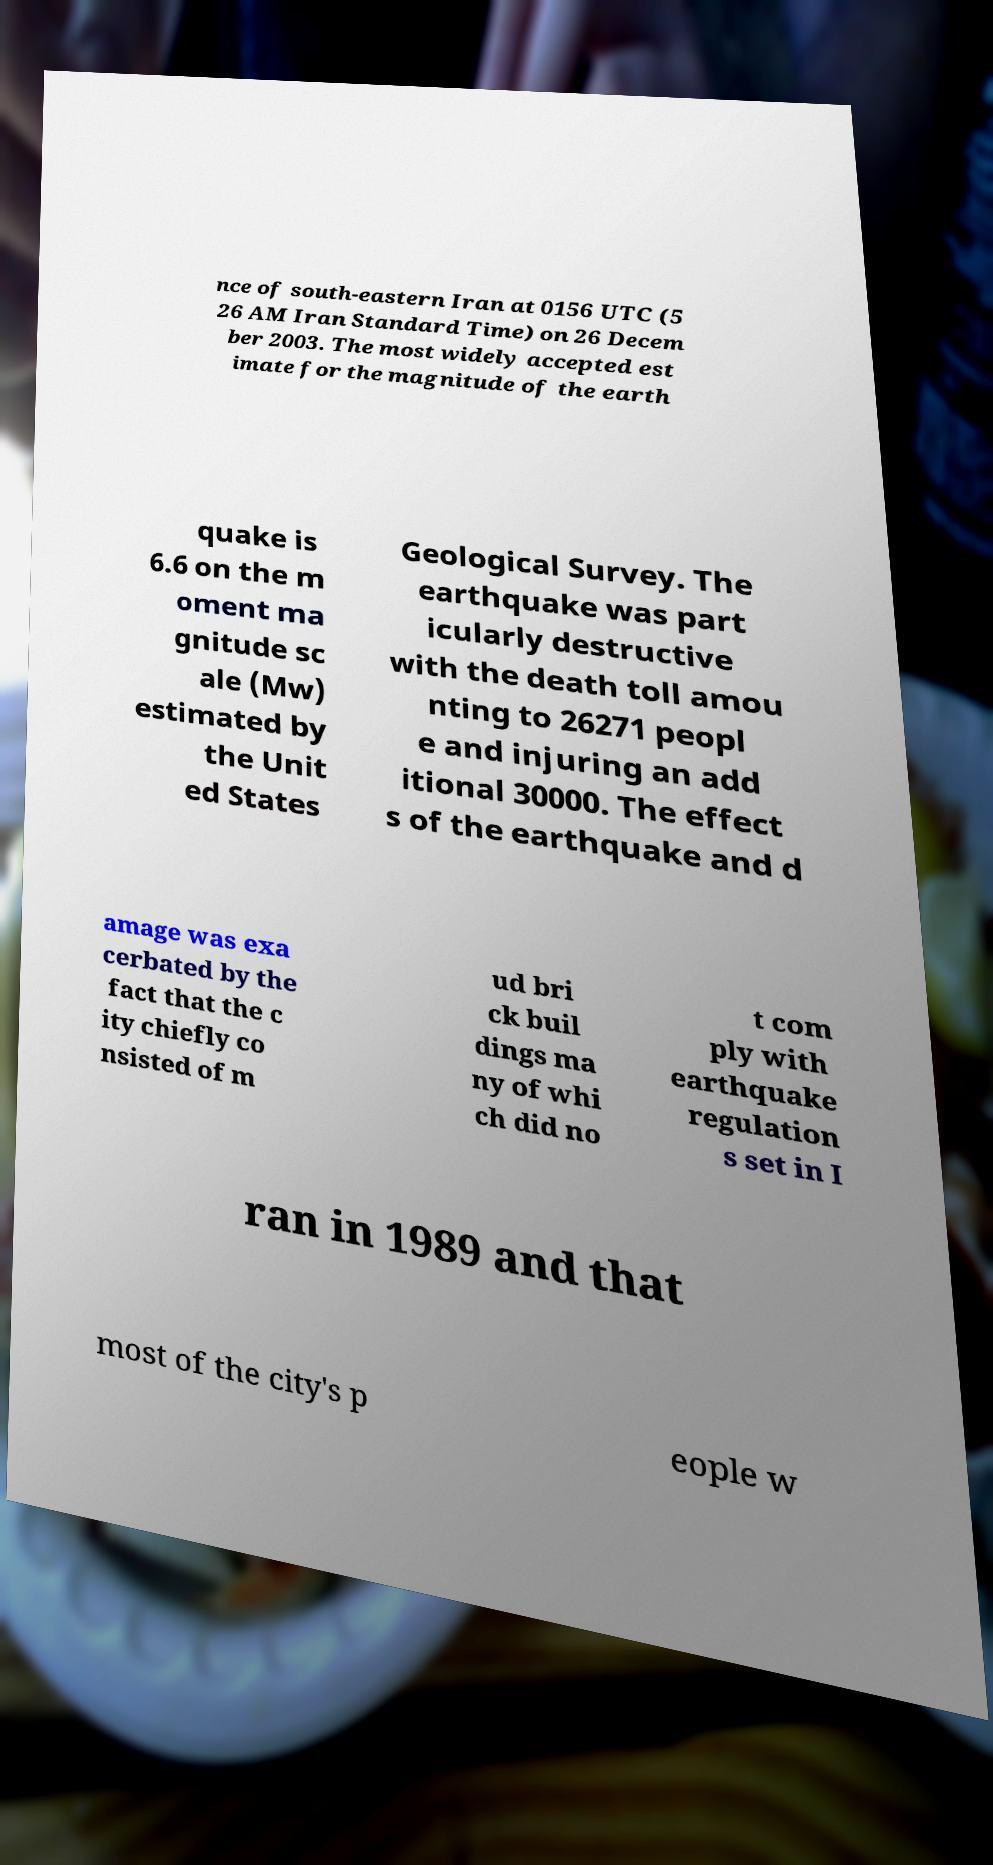Could you extract and type out the text from this image? nce of south-eastern Iran at 0156 UTC (5 26 AM Iran Standard Time) on 26 Decem ber 2003. The most widely accepted est imate for the magnitude of the earth quake is 6.6 on the m oment ma gnitude sc ale (Mw) estimated by the Unit ed States Geological Survey. The earthquake was part icularly destructive with the death toll amou nting to 26271 peopl e and injuring an add itional 30000. The effect s of the earthquake and d amage was exa cerbated by the fact that the c ity chiefly co nsisted of m ud bri ck buil dings ma ny of whi ch did no t com ply with earthquake regulation s set in I ran in 1989 and that most of the city's p eople w 